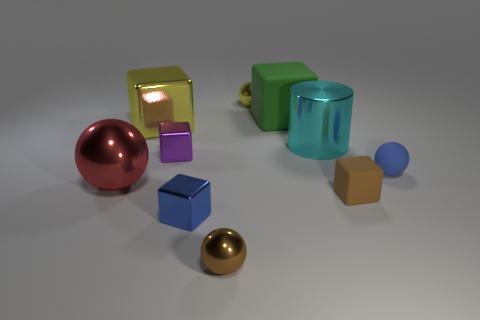Subtract 1 spheres. How many spheres are left? 3 Subtract all cylinders. How many objects are left? 9 Subtract 0 gray cubes. How many objects are left? 10 Subtract all large cyan shiny cylinders. Subtract all purple cubes. How many objects are left? 8 Add 5 big yellow metallic things. How many big yellow metallic things are left? 6 Add 9 large cyan metal cylinders. How many large cyan metal cylinders exist? 10 